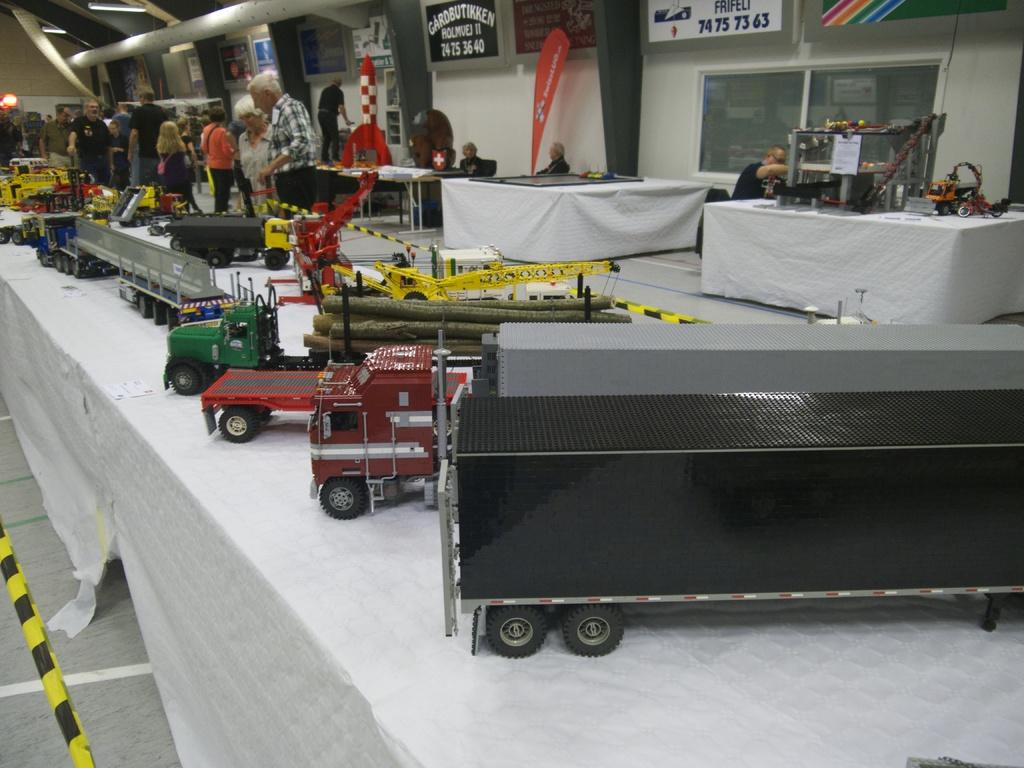What is located in the foreground of the image? There are toys in the foreground of the image. What can be seen in the background of the image? People are visible in the background of the image. What are the people doing in the image? The people are watching the toys. What position does the duck hold in the image? There is no duck present in the image. What color is the crayon used to draw on the toys? There is no crayon or drawing on the toys in the image. 